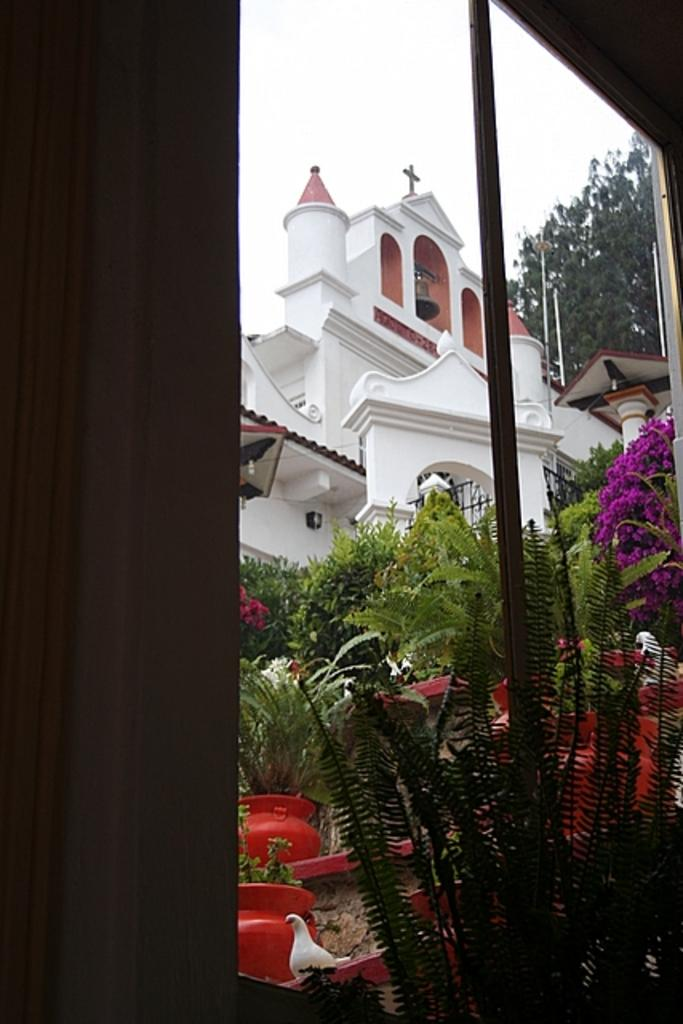What is present in the image that allows light to enter the room? There is a window in the image. What is used to cover the window? There is a curtain associated with the window. What type of living organisms can be seen in the image? Birds and plants are visible in the image. What objects are present that hold the plants? There are pots in the image. What type of decorative elements can be seen in the image? There are flowers in the image. What can be seen in the background of the image? There is a building, a tree, and poles in the background of the image. What part of the natural environment is visible in the image? The sky is visible in the background of the image. How many crates are stacked next to the tree in the image? There are no crates present in the image. 